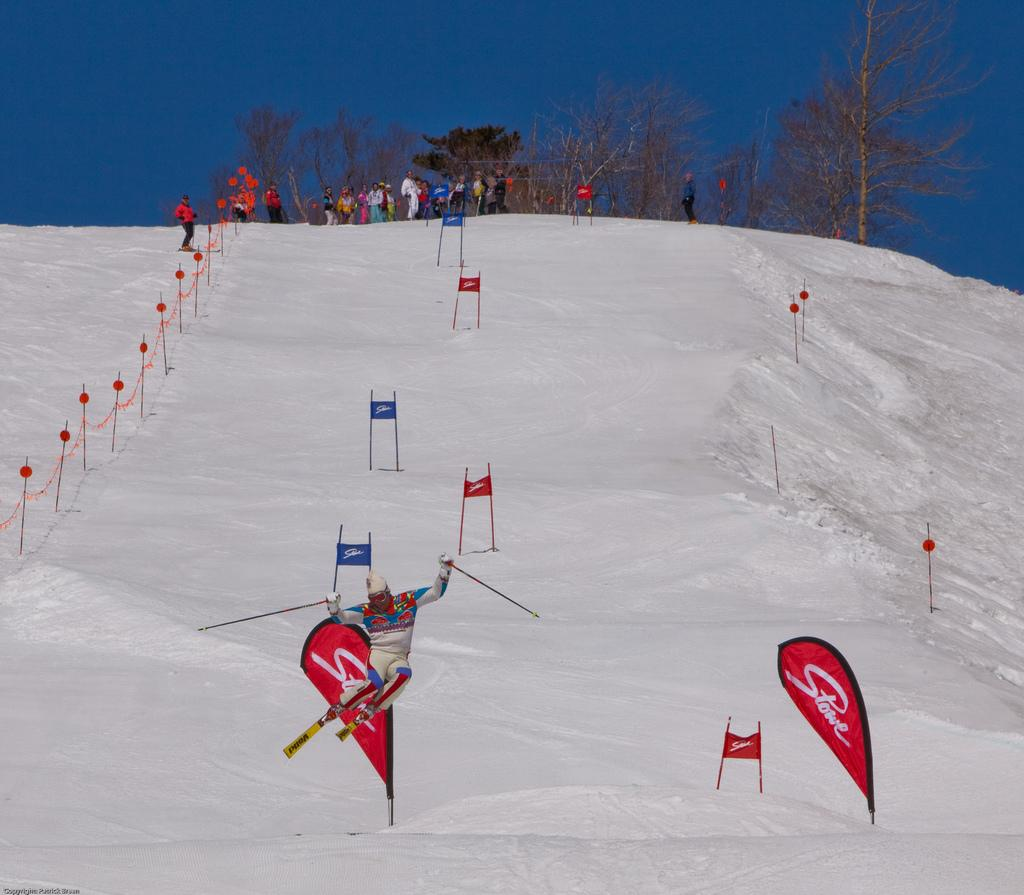<image>
Present a compact description of the photo's key features. Skiers go down a snowy hill with red flags on it that say Stowe. 